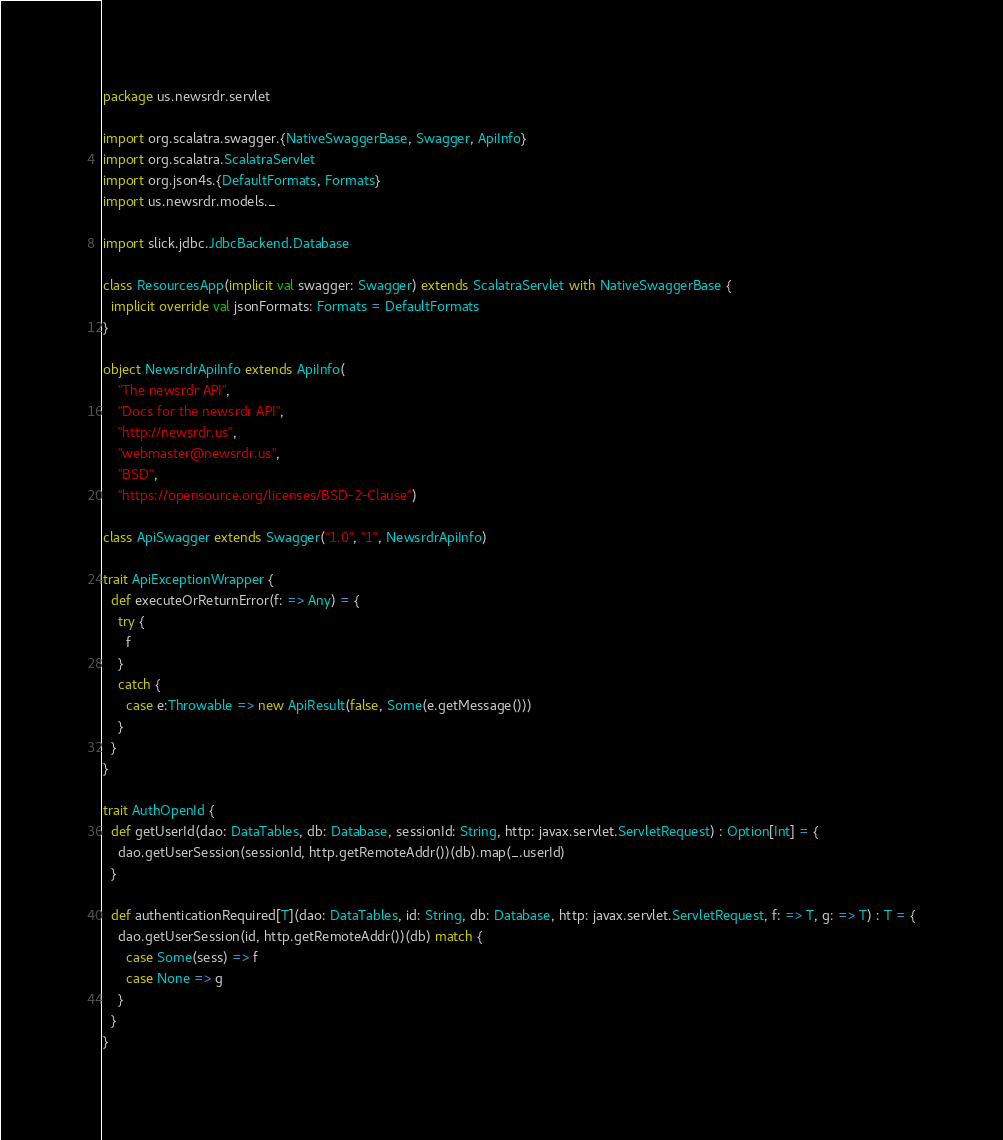Convert code to text. <code><loc_0><loc_0><loc_500><loc_500><_Scala_>package us.newsrdr.servlet

import org.scalatra.swagger.{NativeSwaggerBase, Swagger, ApiInfo}
import org.scalatra.ScalatraServlet
import org.json4s.{DefaultFormats, Formats}
import us.newsrdr.models._

import slick.jdbc.JdbcBackend.Database

class ResourcesApp(implicit val swagger: Swagger) extends ScalatraServlet with NativeSwaggerBase {
  implicit override val jsonFormats: Formats = DefaultFormats
}

object NewsrdrApiInfo extends ApiInfo(
    "The newsrdr API",
    "Docs for the newsrdr API",
    "http://newsrdr.us",
    "webmaster@newsrdr.us",
    "BSD",
    "https://opensource.org/licenses/BSD-2-Clause")

class ApiSwagger extends Swagger("1.0", "1", NewsrdrApiInfo)

trait ApiExceptionWrapper {
  def executeOrReturnError(f: => Any) = {
    try {
      f
    }
    catch {
      case e:Throwable => new ApiResult(false, Some(e.getMessage()))
    }
  }
}

trait AuthOpenId {
  def getUserId(dao: DataTables, db: Database, sessionId: String, http: javax.servlet.ServletRequest) : Option[Int] = {
    dao.getUserSession(sessionId, http.getRemoteAddr())(db).map(_.userId)
  }
    
  def authenticationRequired[T](dao: DataTables, id: String, db: Database, http: javax.servlet.ServletRequest, f: => T, g: => T) : T = {
    dao.getUserSession(id, http.getRemoteAddr())(db) match {
      case Some(sess) => f
      case None => g
    }
  }
}
</code> 